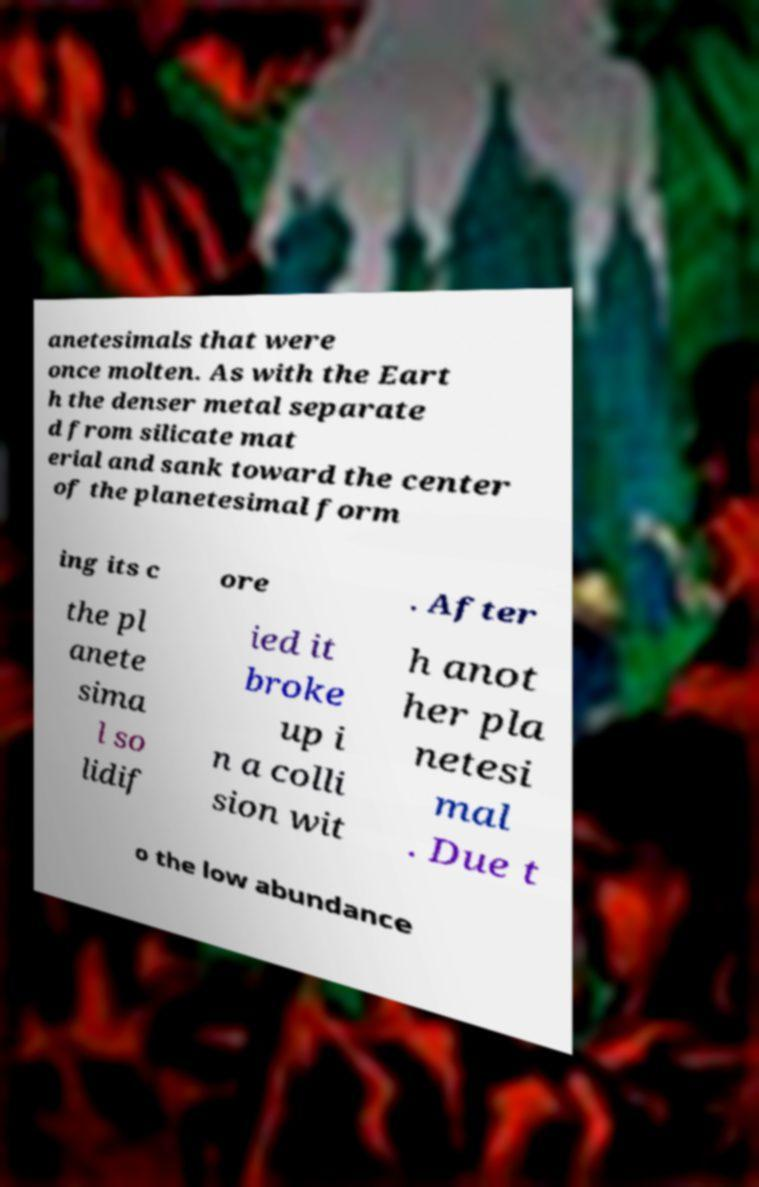Can you accurately transcribe the text from the provided image for me? anetesimals that were once molten. As with the Eart h the denser metal separate d from silicate mat erial and sank toward the center of the planetesimal form ing its c ore . After the pl anete sima l so lidif ied it broke up i n a colli sion wit h anot her pla netesi mal . Due t o the low abundance 